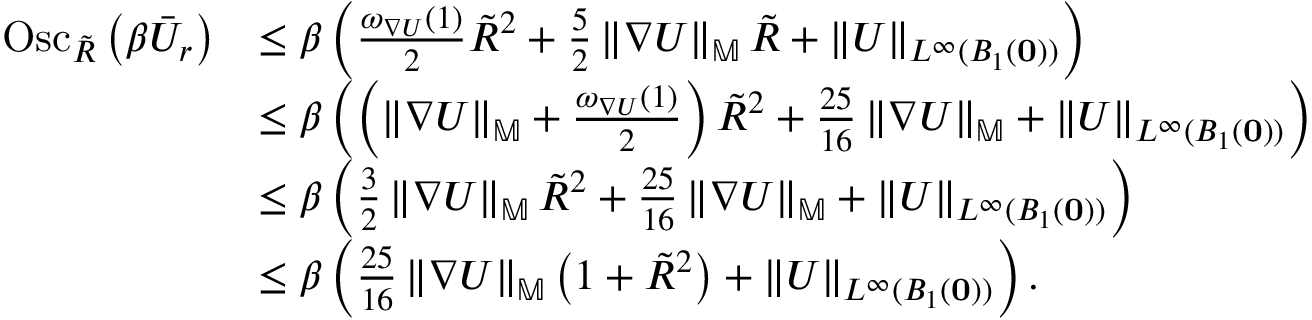<formula> <loc_0><loc_0><loc_500><loc_500>\begin{array} { r l } { O s c _ { \tilde { R } } \left ( \beta \ B a r { U } _ { r } \right ) } & { \leq \beta \left ( \frac { \omega _ { \nabla U } ( 1 ) } { 2 } \tilde { R } ^ { 2 } + \frac { 5 } { 2 } \left \| \nabla U \right \| _ { \mathbb { M } } \tilde { R } + \left \| U \right \| _ { L ^ { \infty } ( B _ { 1 } ( 0 ) ) } \right ) } \\ & { \leq \beta \left ( \left ( \left \| \nabla U \right \| _ { \mathbb { M } } + \frac { \omega _ { \nabla U } ( 1 ) } { 2 } \right ) \tilde { R } ^ { 2 } + \frac { 2 5 } { 1 6 } \left \| \nabla U \right \| _ { \mathbb { M } } + \left \| U \right \| _ { L ^ { \infty } ( B _ { 1 } ( 0 ) ) } \right ) } \\ & { \leq \beta \left ( \frac { 3 } { 2 } \left \| \nabla U \right \| _ { \mathbb { M } } \tilde { R } ^ { 2 } + \frac { 2 5 } { 1 6 } \left \| \nabla U \right \| _ { \mathbb { M } } + \left \| U \right \| _ { L ^ { \infty } ( B _ { 1 } ( 0 ) ) } \right ) } \\ & { \leq \beta \left ( \frac { 2 5 } { 1 6 } \left \| \nabla U \right \| _ { \mathbb { M } } \left ( 1 + \tilde { R } ^ { 2 } \right ) + \left \| U \right \| _ { L ^ { \infty } ( B _ { 1 } ( 0 ) ) } \right ) . } \end{array}</formula> 